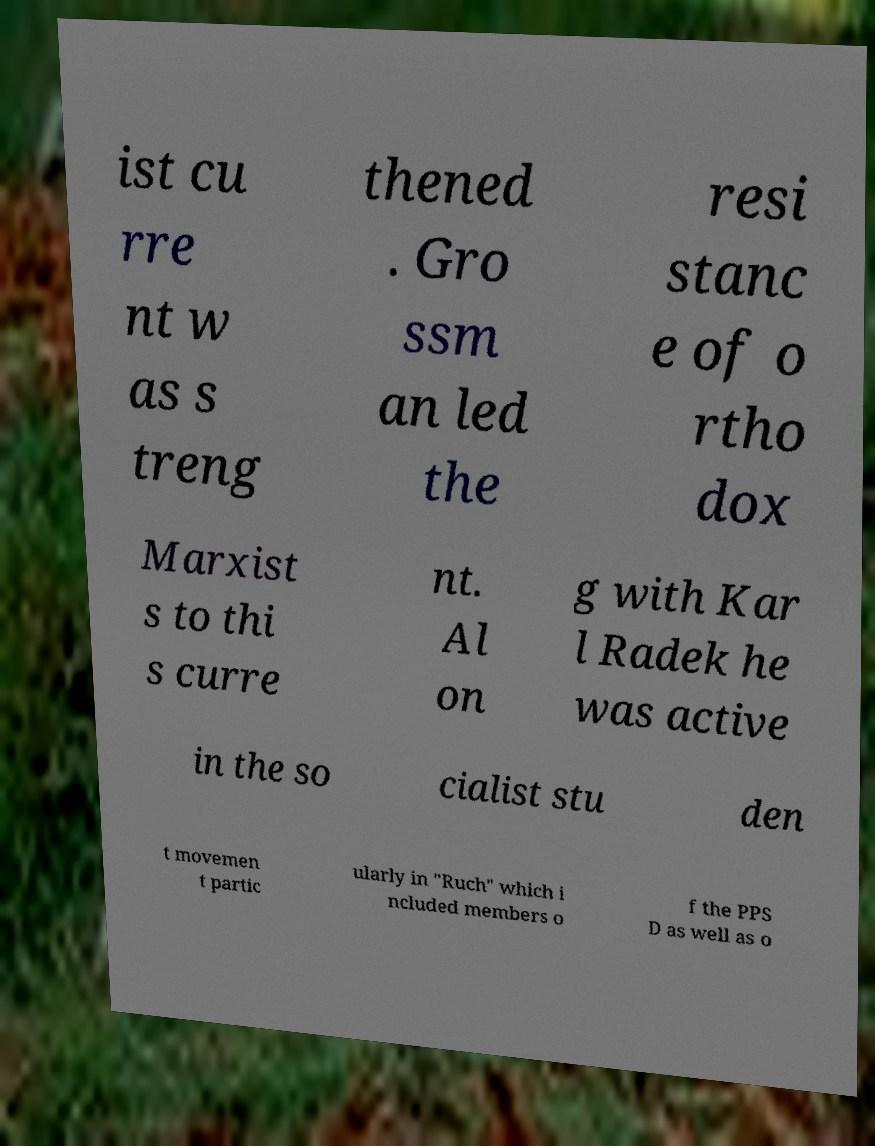Please identify and transcribe the text found in this image. ist cu rre nt w as s treng thened . Gro ssm an led the resi stanc e of o rtho dox Marxist s to thi s curre nt. Al on g with Kar l Radek he was active in the so cialist stu den t movemen t partic ularly in "Ruch" which i ncluded members o f the PPS D as well as o 